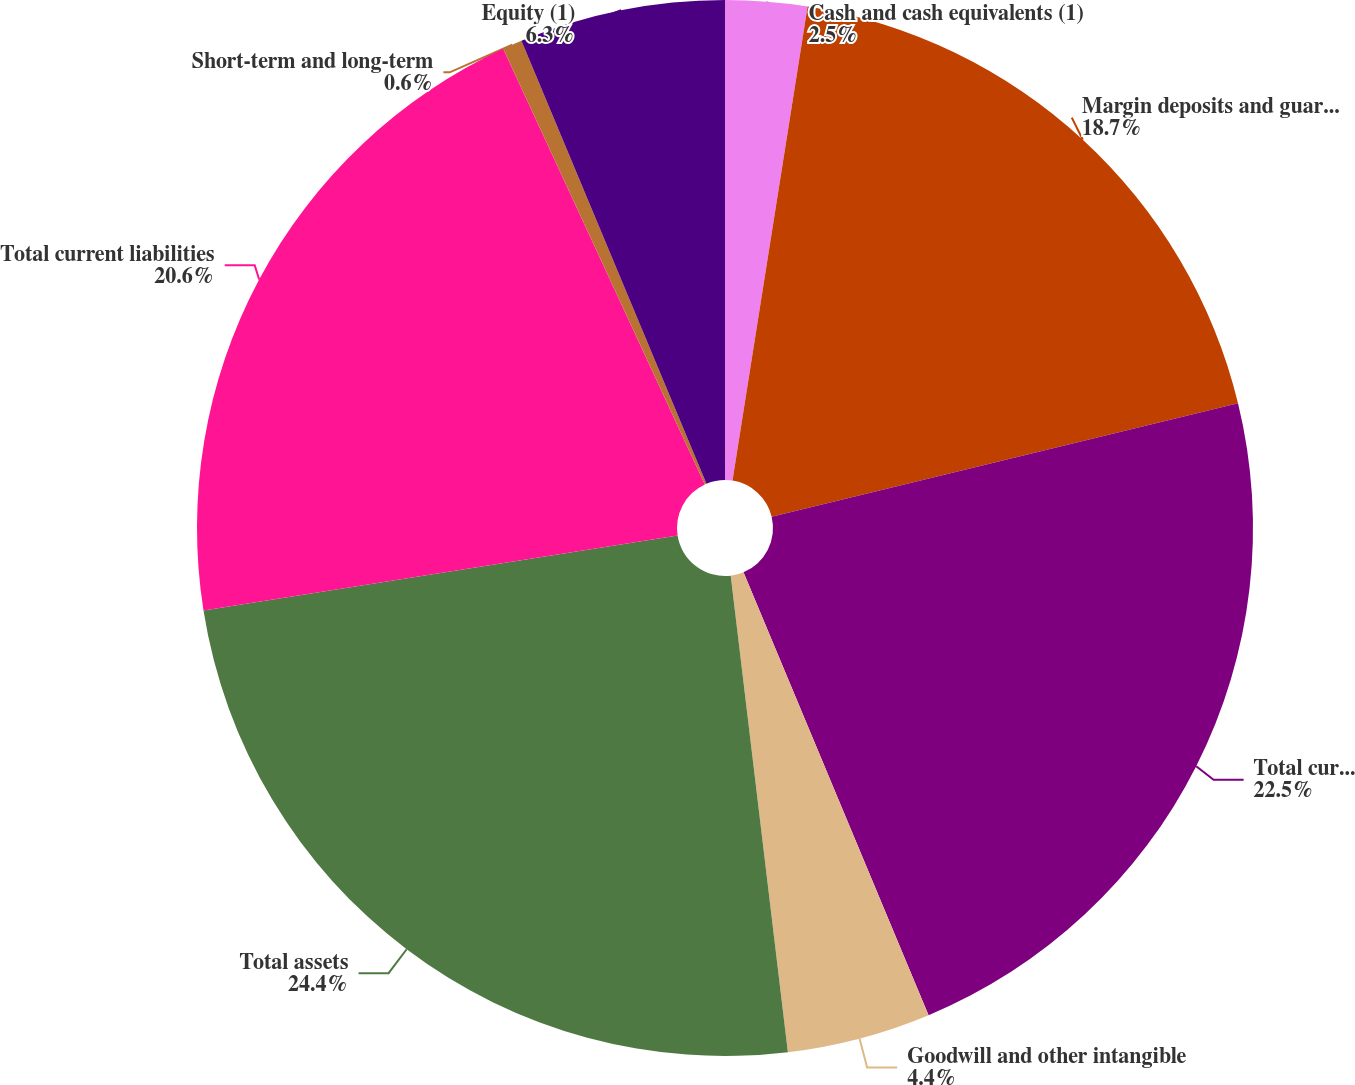<chart> <loc_0><loc_0><loc_500><loc_500><pie_chart><fcel>Cash and cash equivalents (1)<fcel>Margin deposits and guaranty<fcel>Total current assets<fcel>Goodwill and other intangible<fcel>Total assets<fcel>Total current liabilities<fcel>Short-term and long-term<fcel>Equity (1)<nl><fcel>2.5%<fcel>18.7%<fcel>22.5%<fcel>4.4%<fcel>24.4%<fcel>20.6%<fcel>0.6%<fcel>6.3%<nl></chart> 